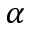<formula> <loc_0><loc_0><loc_500><loc_500>\alpha</formula> 